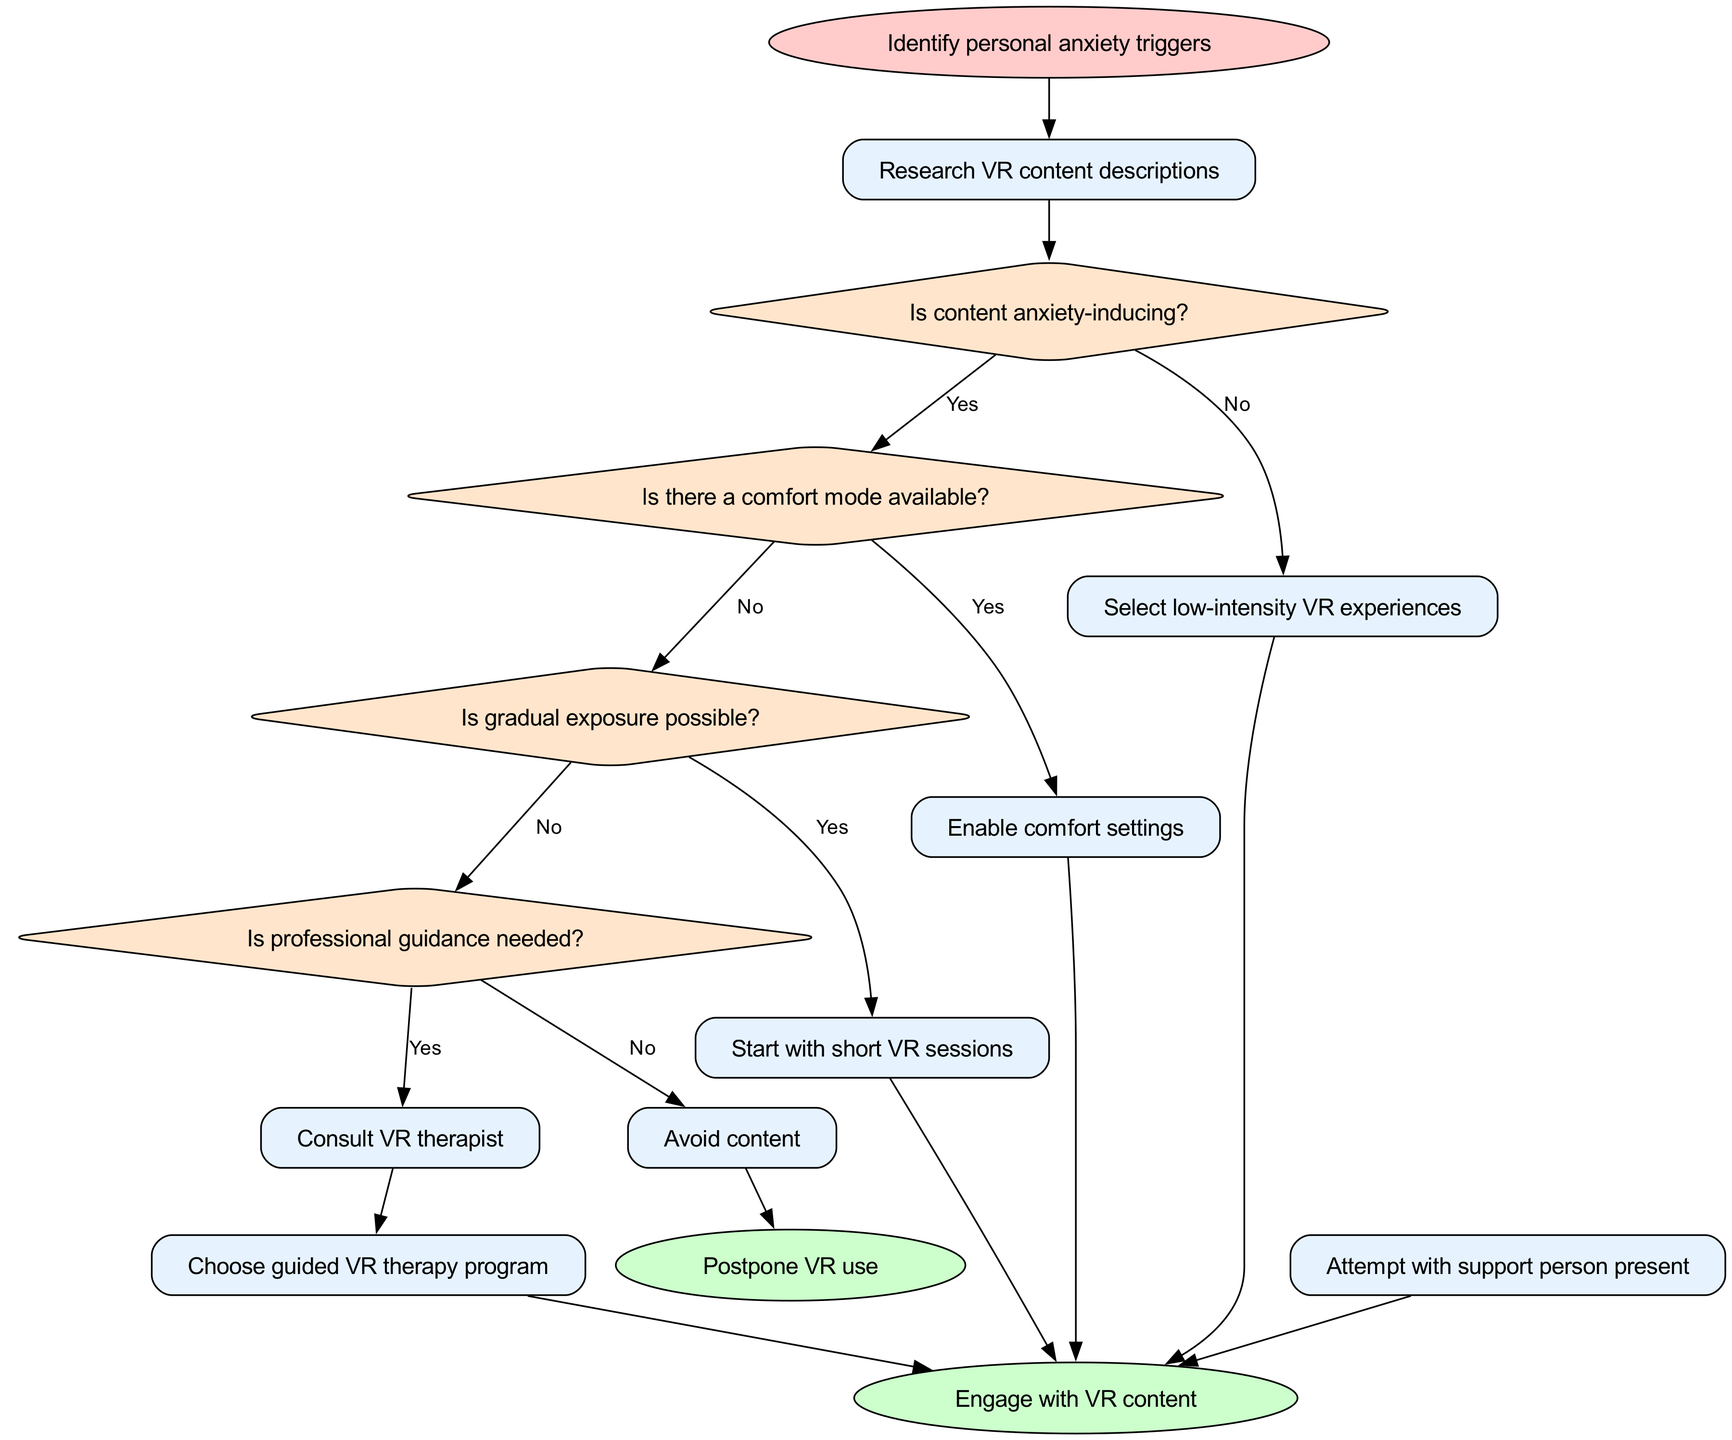What is the starting point of the flow chart? The flow chart begins with the node labeled "Identify personal anxiety triggers." This node represents the initial step in the decision-making process depicted in the diagram.
Answer: Identify personal anxiety triggers How many decision nodes are present in the diagram? There are four decision nodes in the diagram. They are "Is content anxiety-inducing?", "Is there a comfort mode available?", "Is gradual exposure possible?", and "Is professional guidance needed?". These nodes help determine the path based on individual preferences and reactions.
Answer: 4 What action should be taken if the content is not anxiety-inducing? If the content is determined to be not anxiety-inducing, the recommended action is to "Select low-intensity VR experiences." This choice is made directly from the decision node related to the anxiety-inducing content.
Answer: Select low-intensity VR experiences What happens if professional guidance is deemed not necessary? If it is determined that professional guidance is not needed, the next step is to "Avoid content." This conclusion is drawn from the decision node that assesses the need for professional support.
Answer: Avoid content If there is a comfort mode available, what is the next action? When a comfort mode is available, the next action is to "Enable comfort settings." This follows directly from the decision node that confirms the availability of comfort options.
Answer: Enable comfort settings Which action leads directly to engaging with VR content? Several actions lead to "Engage with VR content." They include "Enable comfort settings," "Select low-intensity VR experiences," "Start with short VR sessions," and "Choose guided VR therapy program." Each of these actions connects to the end node focused on engaging with VR.
Answer: Enable comfort settings, Select low-intensity VR experiences, Start with short VR sessions, Choose guided VR therapy program What should someone do if they are uncomfortable proceeding without support? If an individual feels uncomfortable proceeding alone, they should "Attempt with support person present." This step is important for ensuring comfort and reducing anxiety during the experience.
Answer: Attempt with support person present If someone consults a therapist, where does that lead? Consulting a therapist leads to the action of "Choose guided VR therapy program." This step indicates a structured approach to using VR with professional assistance to manage anxiety effectively.
Answer: Choose guided VR therapy program What is the outcome if the user decides to avoid content? If the user decides to avoid content, the outcome is to "Postpone VR use." This conclusion serves as a clear action for managing personal triggers by stepping back from VR experiences altogether.
Answer: Postpone VR use 